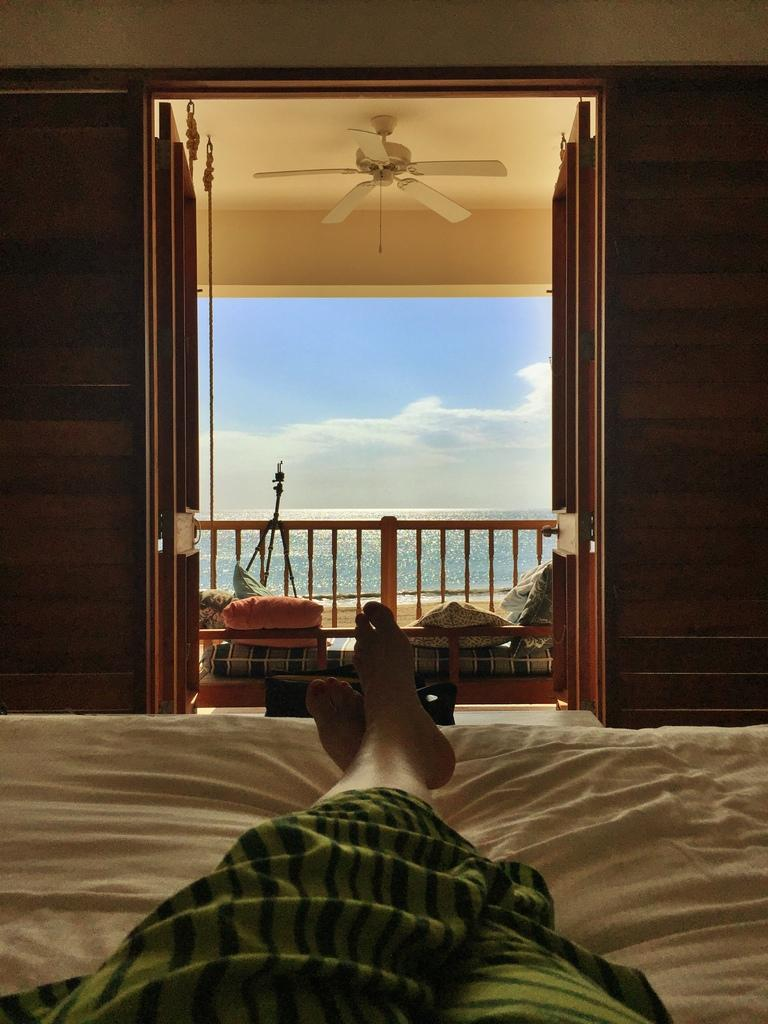What is the person in the image doing? There is a person lying on the bed in the image. What can be seen in the background of the image? There is a sofa, a fence, a fan, water, and clouds visible in the background of the image. What type of range is visible in the image? There is no range present in the image. What topics are being discussed by the people in the image? There are no people having a discussion in the image; it only shows a person lying on the bed and various objects in the background. 